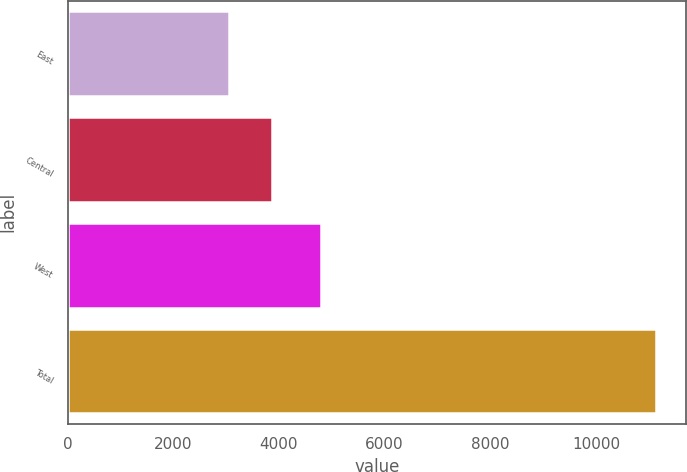Convert chart. <chart><loc_0><loc_0><loc_500><loc_500><bar_chart><fcel>East<fcel>Central<fcel>West<fcel>Total<nl><fcel>3062.3<fcel>3870.62<fcel>4788.5<fcel>11145.5<nl></chart> 